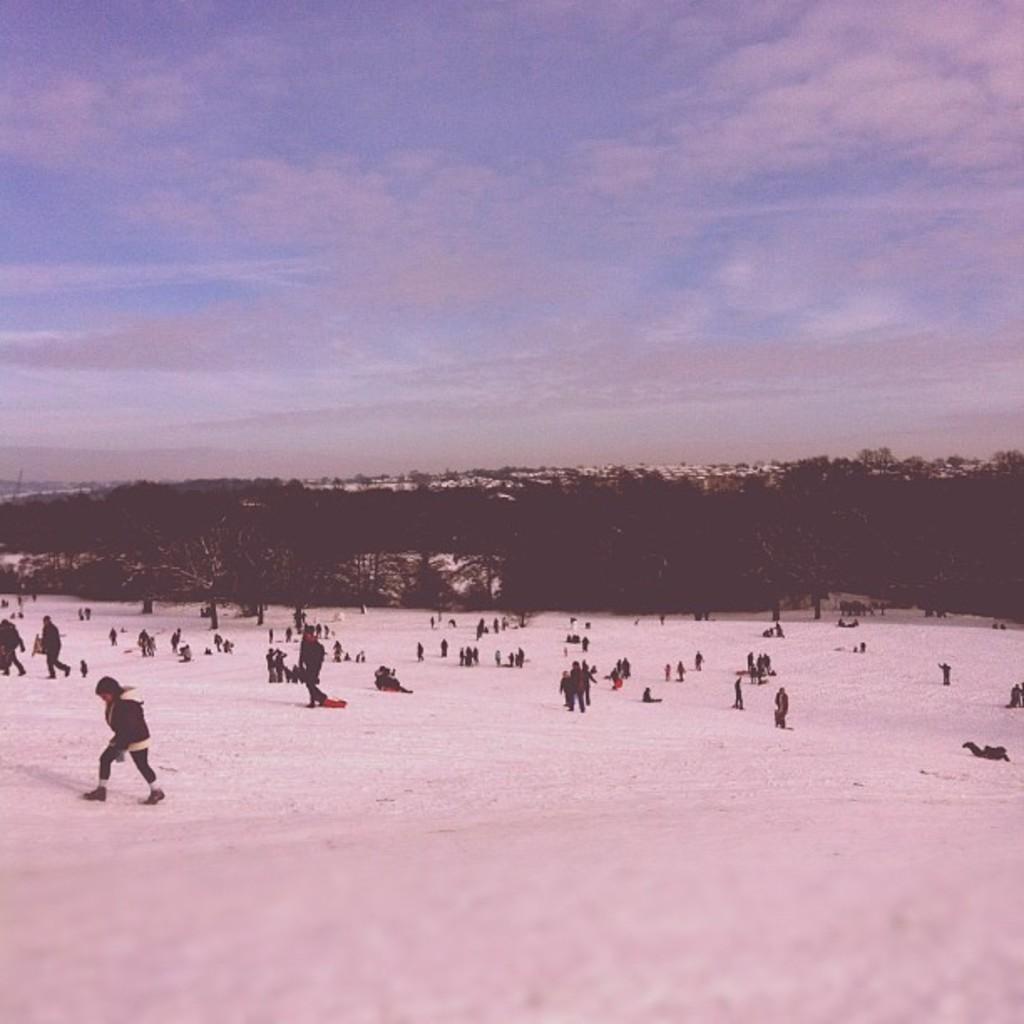Please provide a concise description of this image. In the image I can see some people who are standing and sitting on the snow and also I can see some trees and plants. 